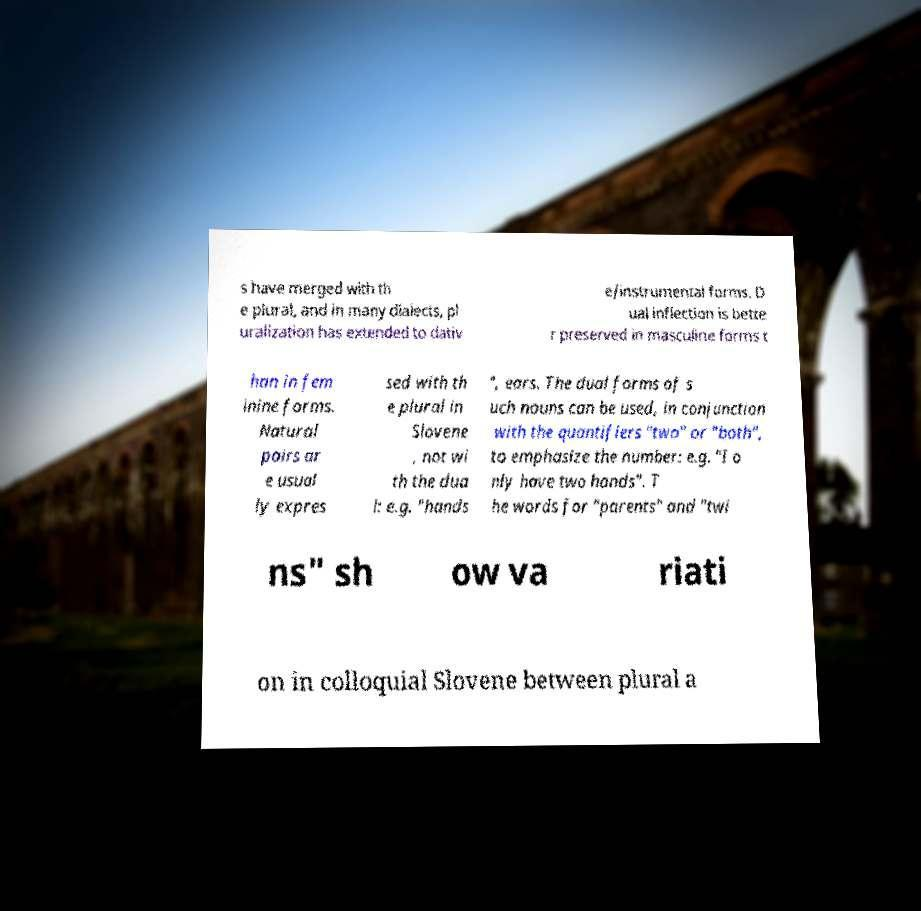For documentation purposes, I need the text within this image transcribed. Could you provide that? s have merged with th e plural, and in many dialects, pl uralization has extended to dativ e/instrumental forms. D ual inflection is bette r preserved in masculine forms t han in fem inine forms. Natural pairs ar e usual ly expres sed with th e plural in Slovene , not wi th the dua l: e.g. "hands ", ears. The dual forms of s uch nouns can be used, in conjunction with the quantifiers "two" or "both", to emphasize the number: e.g. "I o nly have two hands". T he words for "parents" and "twi ns" sh ow va riati on in colloquial Slovene between plural a 